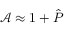<formula> <loc_0><loc_0><loc_500><loc_500>\mathcal { A } \approx 1 + \hat { P }</formula> 